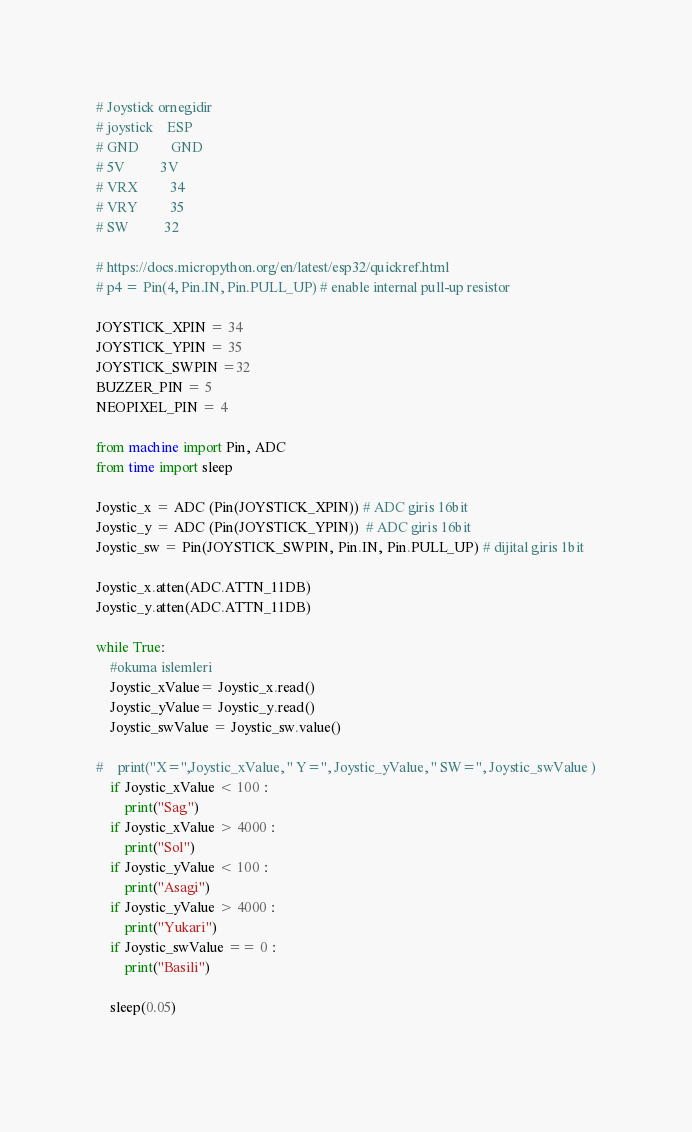Convert code to text. <code><loc_0><loc_0><loc_500><loc_500><_Python_># Joystick ornegidir
# joystick    ESP
# GND         GND
# 5V          3V
# VRX         34
# VRY         35
# SW          32

# https://docs.micropython.org/en/latest/esp32/quickref.html
# p4 = Pin(4, Pin.IN, Pin.PULL_UP) # enable internal pull-up resistor

JOYSTICK_XPIN = 34
JOYSTICK_YPIN = 35
JOYSTICK_SWPIN =32
BUZZER_PIN = 5
NEOPIXEL_PIN = 4

from machine import Pin, ADC
from time import sleep

Joystic_x = ADC (Pin(JOYSTICK_XPIN)) # ADC giris 16bit
Joystic_y = ADC (Pin(JOYSTICK_YPIN))  # ADC giris 16bit
Joystic_sw = Pin(JOYSTICK_SWPIN, Pin.IN, Pin.PULL_UP) # dijital giris 1bit

Joystic_x.atten(ADC.ATTN_11DB)
Joystic_y.atten(ADC.ATTN_11DB)

while True:
    #okuma islemleri
    Joystic_xValue= Joystic_x.read()
    Joystic_yValue= Joystic_y.read()
    Joystic_swValue = Joystic_sw.value()
    
#    print("X=",Joystic_xValue, " Y=", Joystic_yValue, " SW=", Joystic_swValue )
    if Joystic_xValue < 100 :
        print("Sag")
    if Joystic_xValue > 4000 :
        print("Sol")
    if Joystic_yValue < 100 :
        print("Asagi")
    if Joystic_yValue > 4000 :
        print("Yukari")
    if Joystic_swValue == 0 :
        print("Basili")
        
    sleep(0.05)
    </code> 